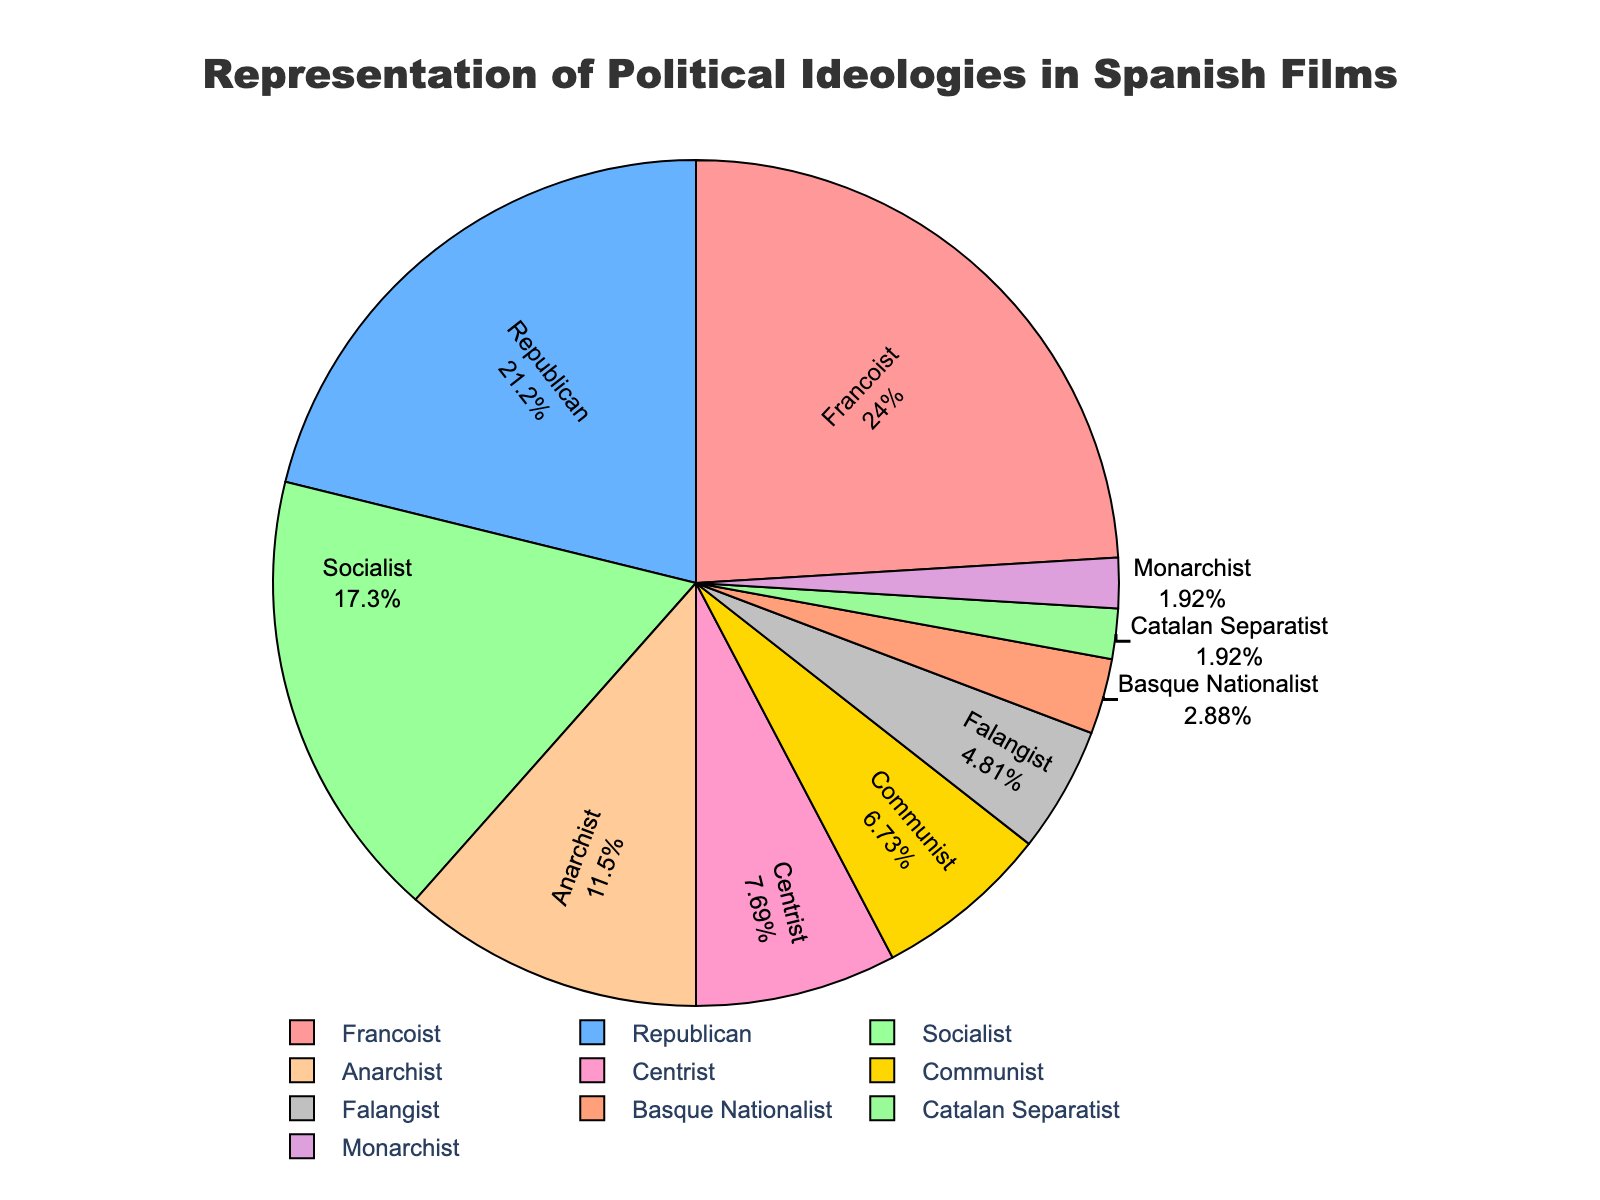What is the ideology with the highest representation? The ideology with the highest representation in the pie chart is identified by finding the largest portion of the chart. The label and percentage for that segment will provide the answer. The Francoist ideology has the largest segment, with 25%.
Answer: Francoist Which two ideologies together have the most representation? To determine this, look for the two segments with the highest percentages and add them together. Francoist has 25%, and Republican has 22%. Adding these gives 25% + 22% = 47%, the largest combined percentage.
Answer: Francoist and Republican How much more represented is the Socialist ideology compared to the Falangist ideology? Identify the percentages for Socialist (18%) and Falangist (5%) segments and subtract the smaller percentage from the larger one: 18% - 5% = 13%.
Answer: 13% Which ideology has the smallest representation and what is its percentage? Look for the segment with the smallest portion in the pie chart. The Catalan Separatist and Monarchist ideologies both have the smallest segment, each with 2%.
Answer: Catalan Separatist and Monarchist with 2% each What is the combined representation of the Anarchist, Centrist, and Communist ideologies? Find the percentages for the Anarchist (12%), Centrist (8%), and Communist (7%) segments and add them together: 12% + 8% + 7% = 27%.
Answer: 27% Compare the representation of Basque Nationalist and Catalan Separatist ideologies. Which one is more represented and by how much? Identify the percentages for Basque Nationalist (3%) and Catalan Separatist (2%) segments. Subtract the smaller percentage from the larger one: 3% - 2% = 1%. Basque Nationalist is more represented.
Answer: Basque Nationalist by 1% Which ideologies together make up exactly half the total representation? To find which ideologies sum up to 50%, check combinations of the percentages. Francoist (25%) and Republican (22%) and Socialist (18%) together amount to 25% + 22% + 18% = 65%, exceeding half. But Francoist (25%) and Socialist (18%) and Anarchist (12%) add up to 25% + 18% + 12% = 55%, nearly half but not exact. Therefore, combining two exact halves such as Francoist (25%) and Anarchist (12%) and Centrist (8%) and Communist (7%) = 25% + 12% + 8% + 7% = 52%, adjacent to exact half. Checking all, Francoist and Republican who alone totals 47%, and included a three figures would greater zero.
Answer: None. None can add exactly 50; closest together some way could not sum up to 50% Which ideology is represented by the red segment in the chart? Refer to the color assigned in the pie chart. The red segment represents Francoist, which matches the given color list and data.
Answer: Francoist How many ideologies have representation percentages in single digits? Look for segments with percentages less than 10%. The ideologies with single-digit percentages are Centrist (8%), Communist (7%), Falangist (5%), Basque Nationalist (3%), Catalan Separatist (2%), Monarchist (2%). There are six ideologies like this.
Answer: Six 